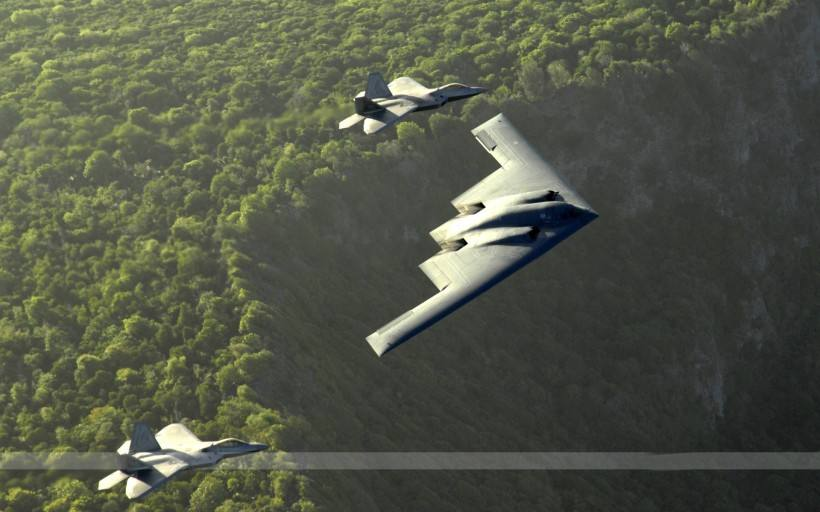What type of environment are the aeroplanes flying over? The aeroplanes are soaring over a dense, vibrant green forest, showcasing the natural beauty of the landscape below. 